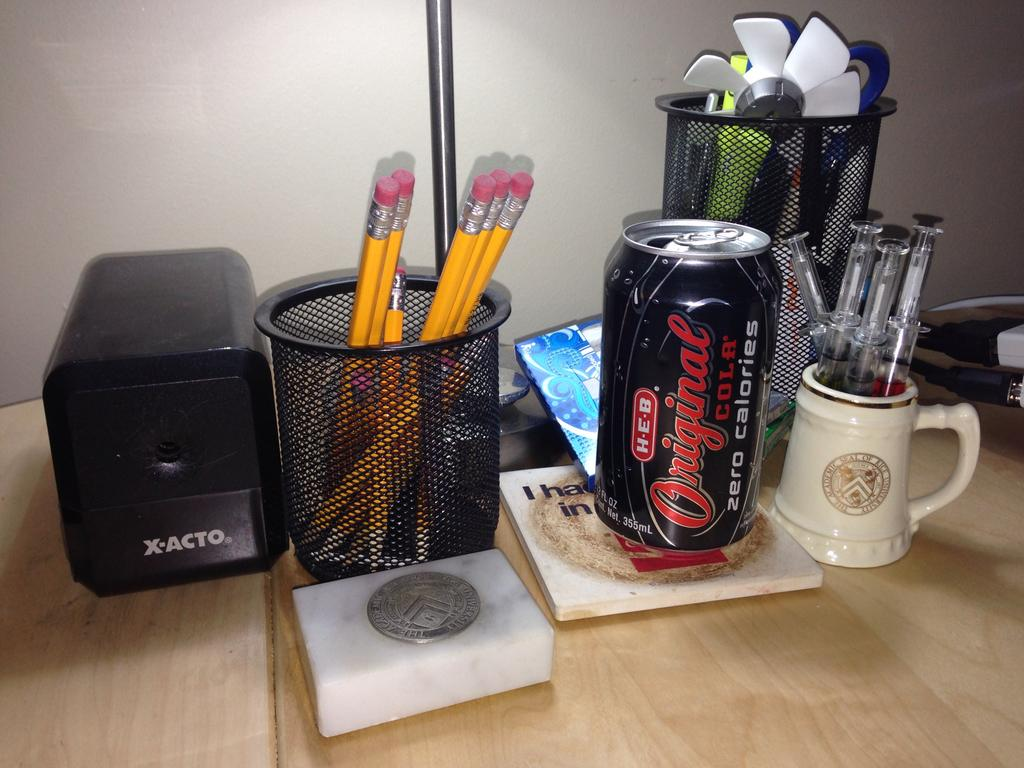<image>
Render a clear and concise summary of the photo. A can of original cola from HEB sits on a desk near some penciles. 